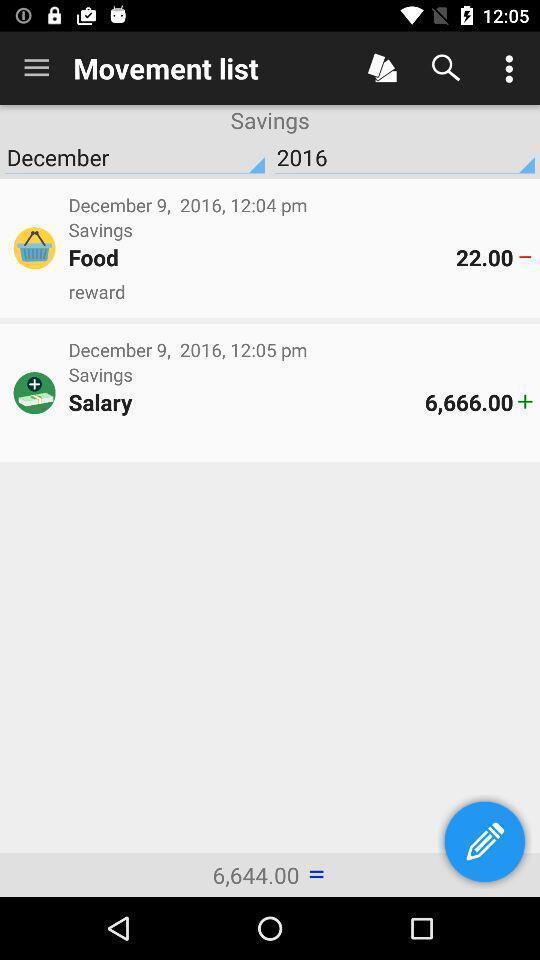Summarize the main components in this picture. Screen displaying movement list page. 